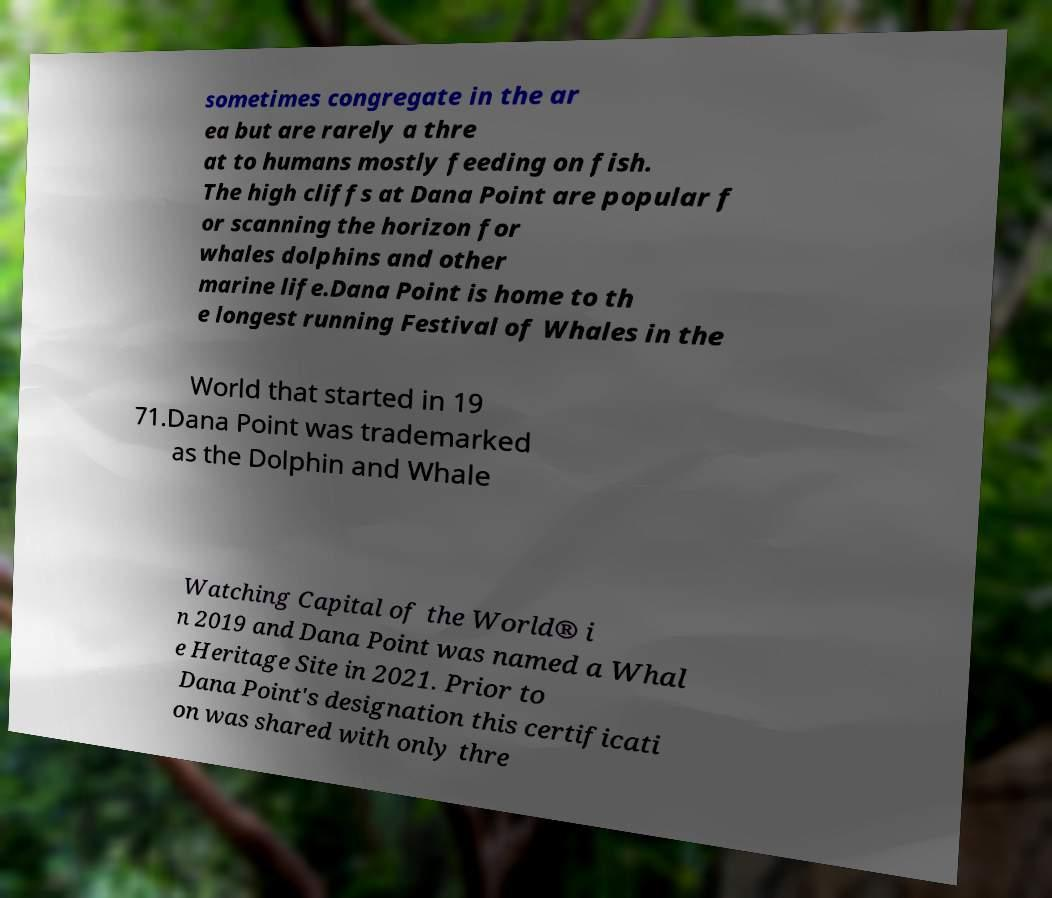Please read and relay the text visible in this image. What does it say? sometimes congregate in the ar ea but are rarely a thre at to humans mostly feeding on fish. The high cliffs at Dana Point are popular f or scanning the horizon for whales dolphins and other marine life.Dana Point is home to th e longest running Festival of Whales in the World that started in 19 71.Dana Point was trademarked as the Dolphin and Whale Watching Capital of the World® i n 2019 and Dana Point was named a Whal e Heritage Site in 2021. Prior to Dana Point's designation this certificati on was shared with only thre 